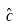Convert formula to latex. <formula><loc_0><loc_0><loc_500><loc_500>\hat { c }</formula> 